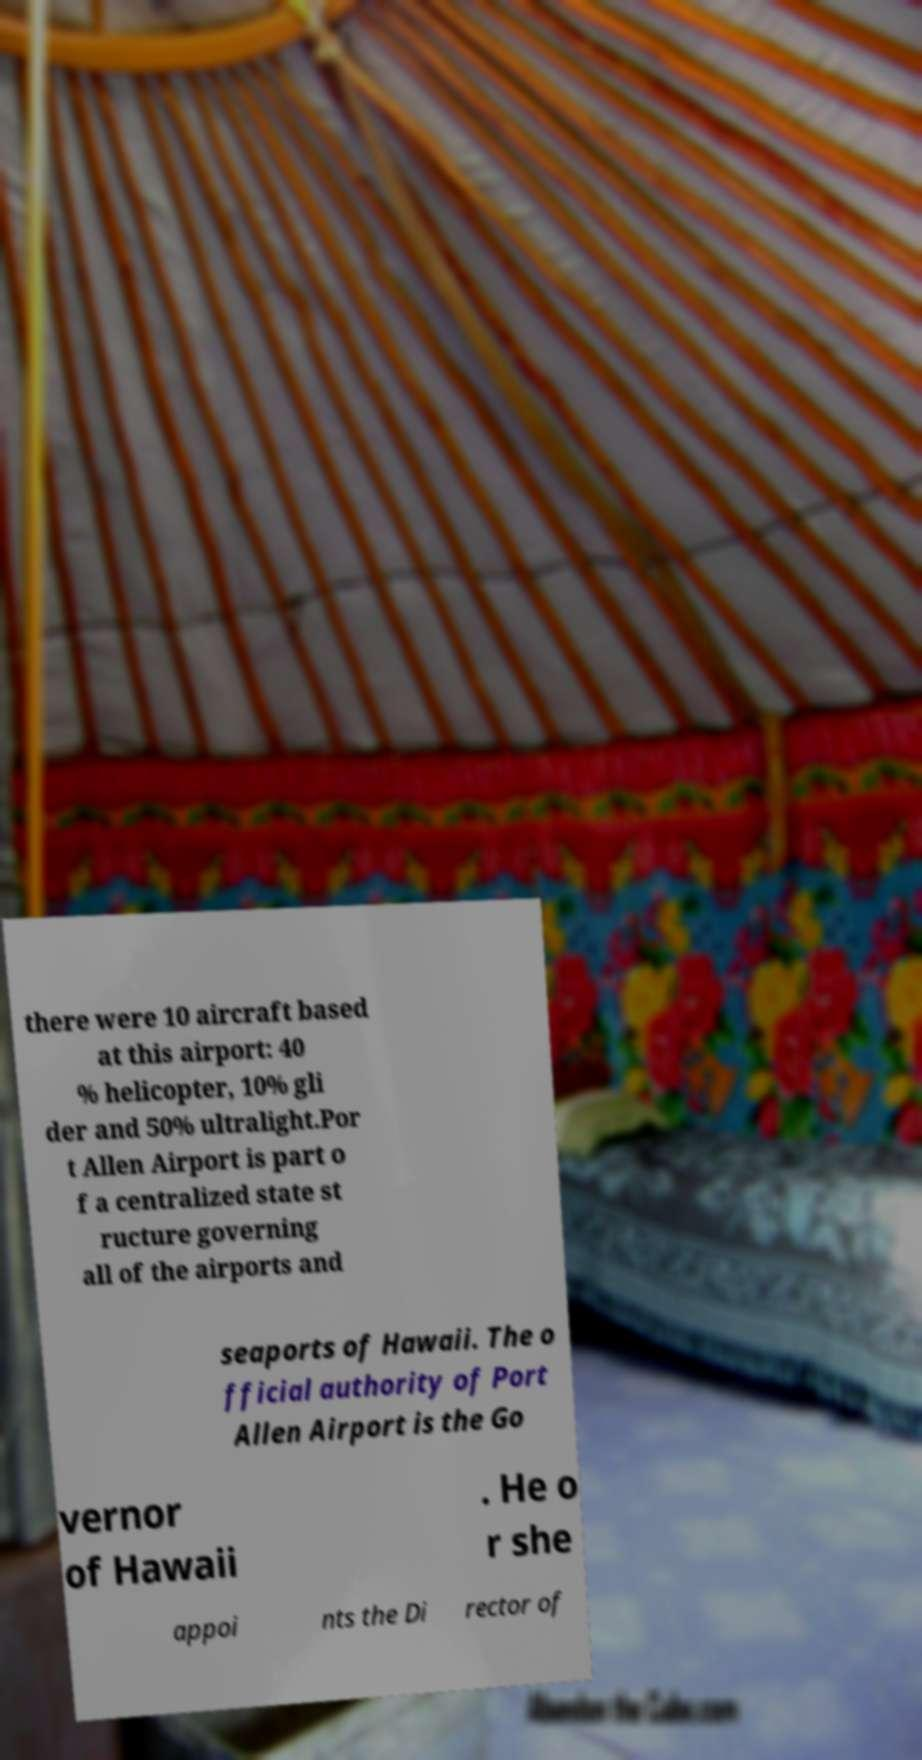For documentation purposes, I need the text within this image transcribed. Could you provide that? there were 10 aircraft based at this airport: 40 % helicopter, 10% gli der and 50% ultralight.Por t Allen Airport is part o f a centralized state st ructure governing all of the airports and seaports of Hawaii. The o fficial authority of Port Allen Airport is the Go vernor of Hawaii . He o r she appoi nts the Di rector of 